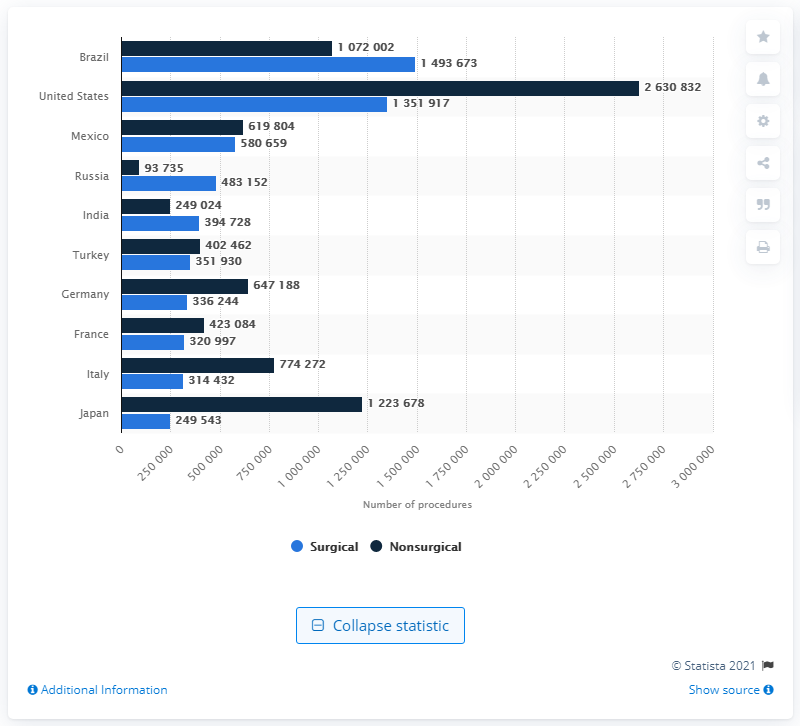Highlight a few significant elements in this photo. In 2020, Brazil reported approximately 1 million nonsurgical cosmetic procedures, and 149,367 surgical procedures. 